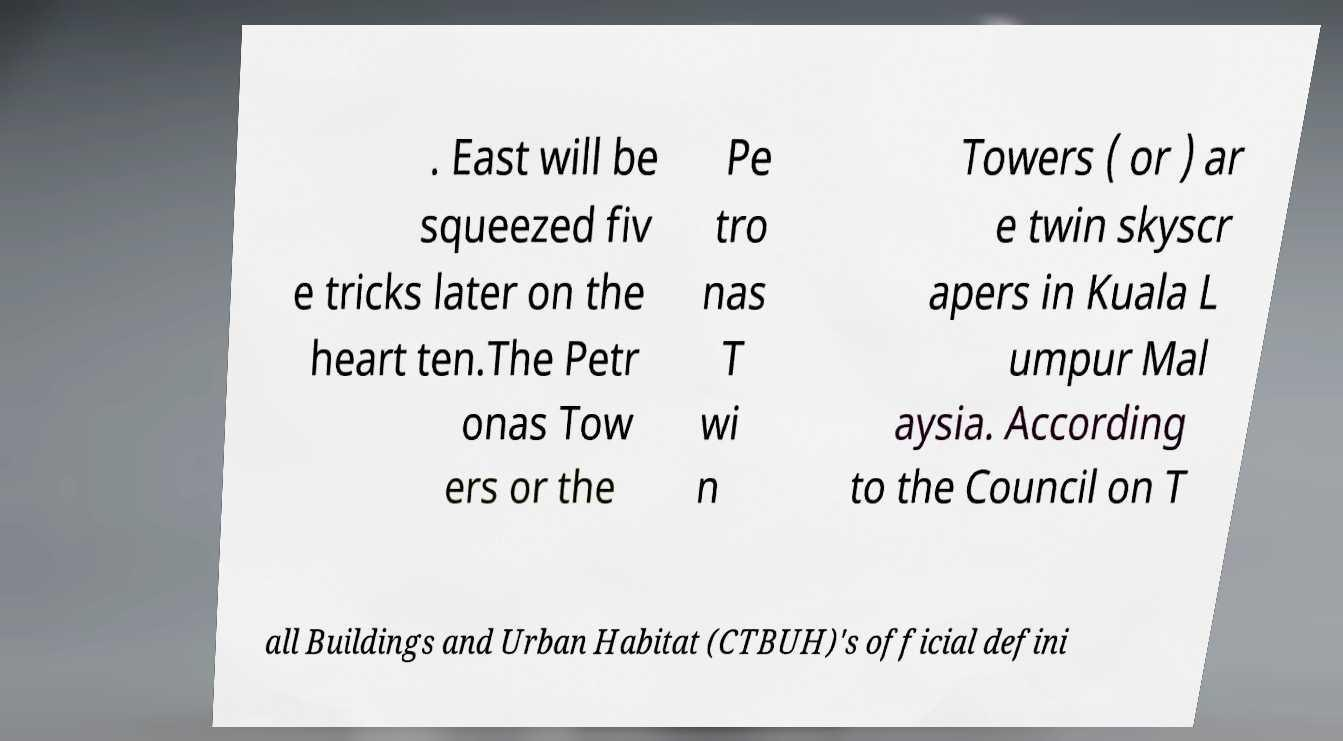What messages or text are displayed in this image? I need them in a readable, typed format. . East will be squeezed fiv e tricks later on the heart ten.The Petr onas Tow ers or the Pe tro nas T wi n Towers ( or ) ar e twin skyscr apers in Kuala L umpur Mal aysia. According to the Council on T all Buildings and Urban Habitat (CTBUH)'s official defini 